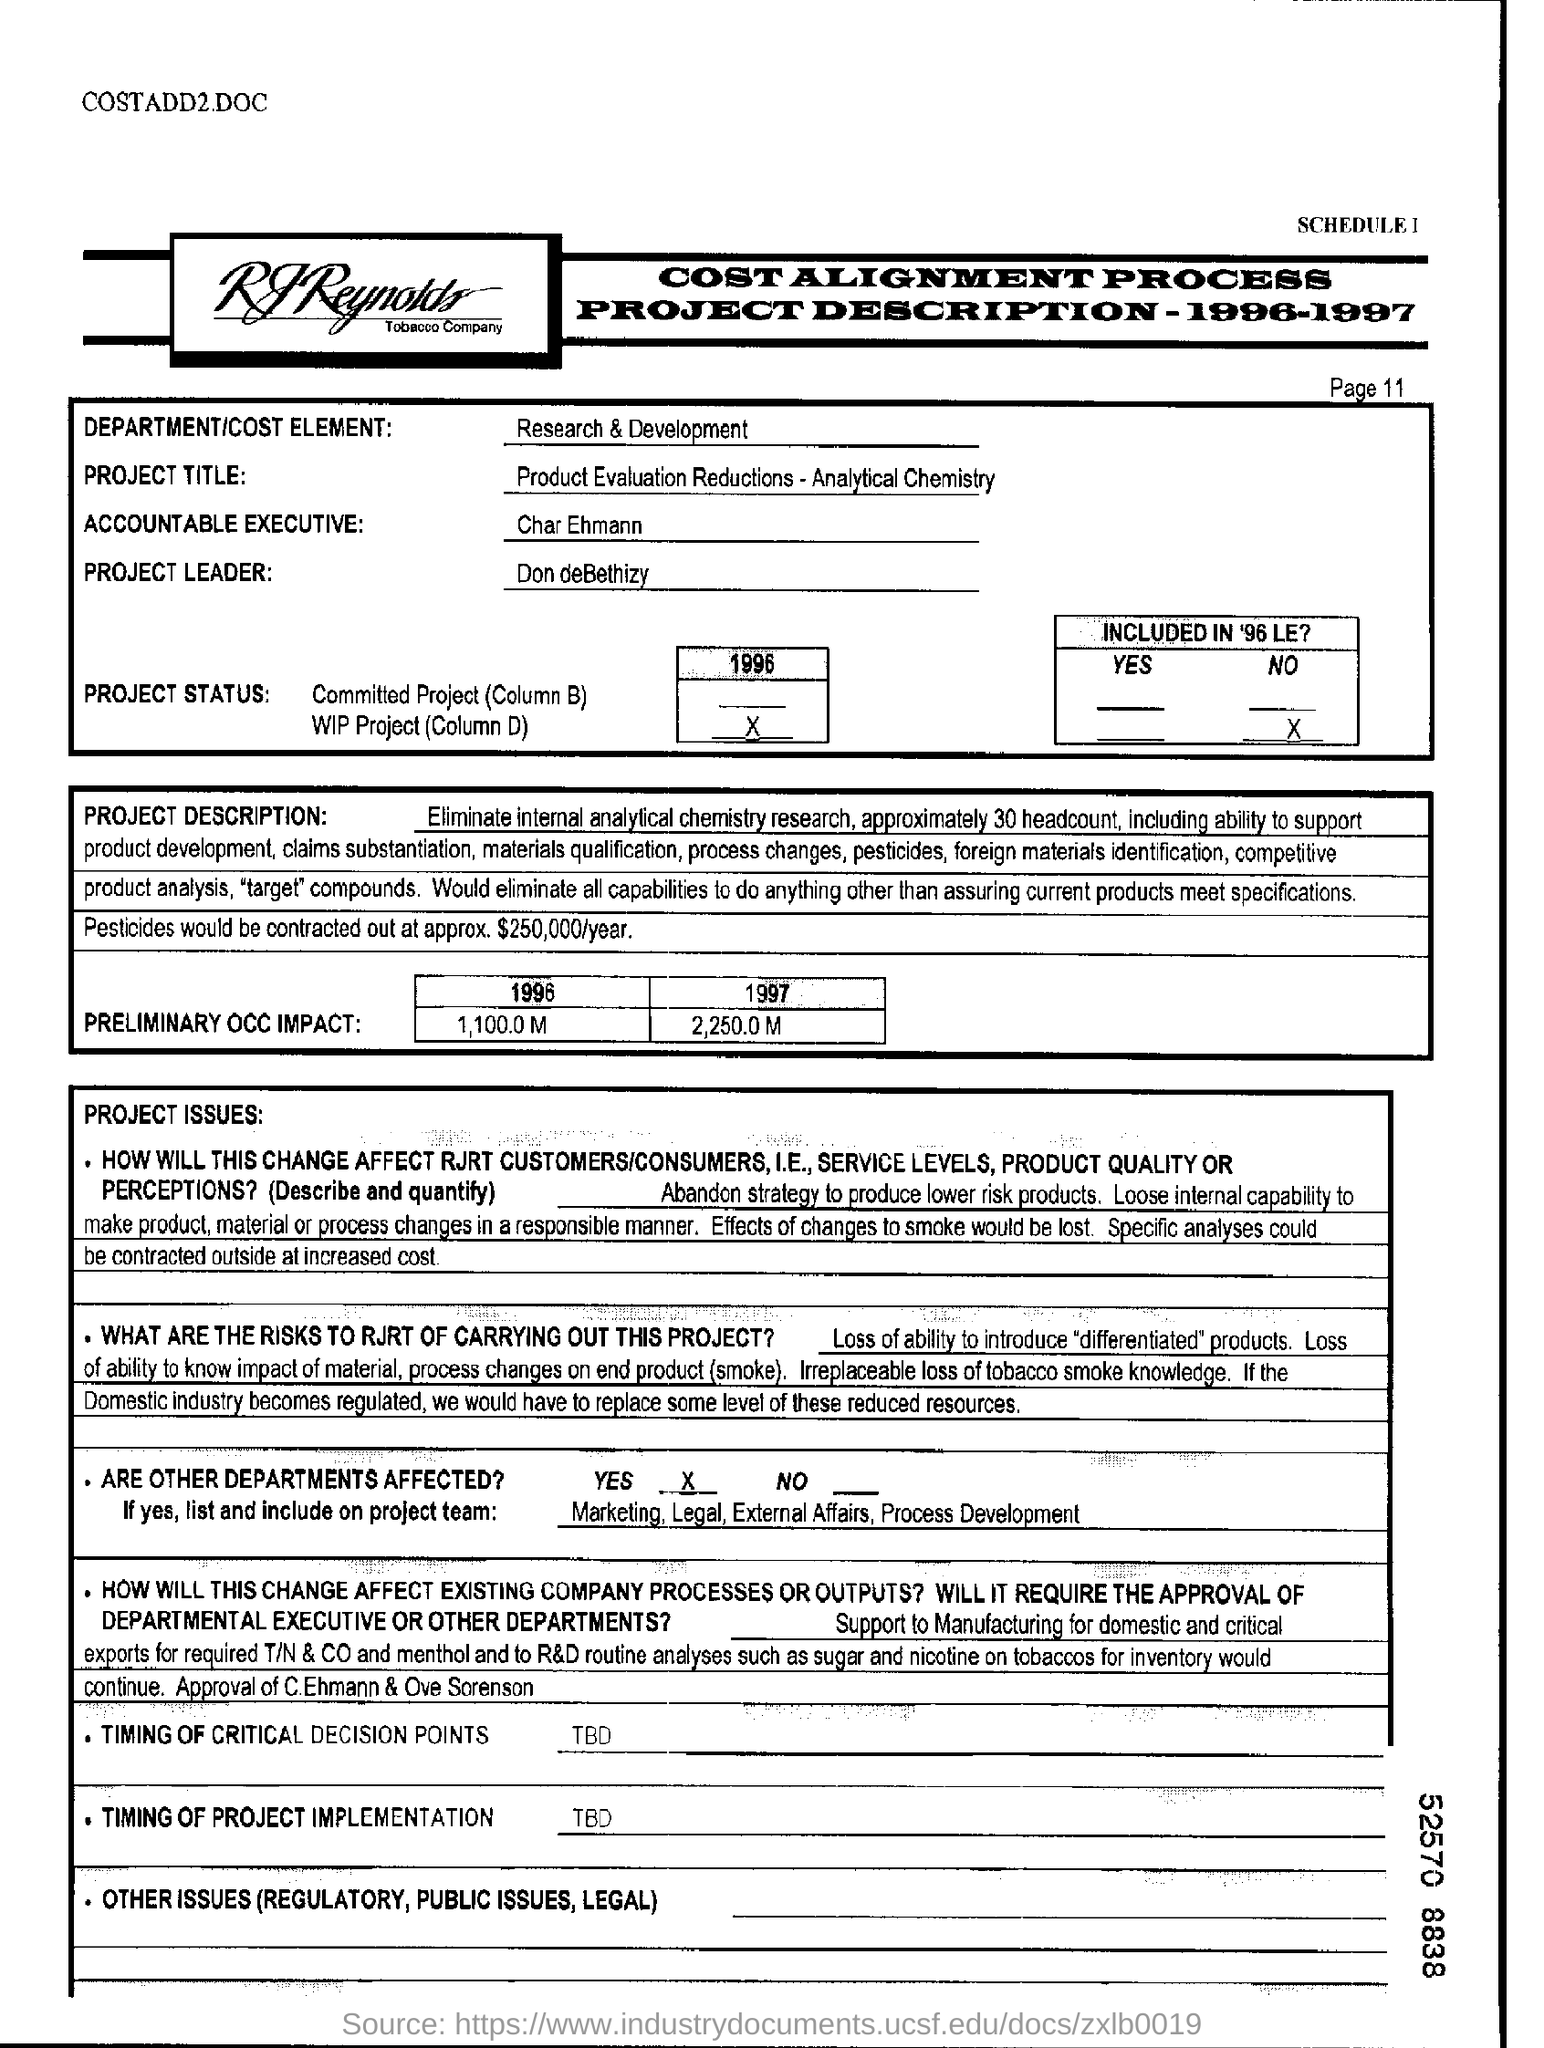Which is the department/cost element given?
Make the answer very short. Research & development. What is the project title?
Your answer should be very brief. Product Evaluation Reductions- Analytical Chemistry. What is the designation of Don deBethizy?
Make the answer very short. Project leader. Who is the accountable executive?
Ensure brevity in your answer.  Char ehmann. Which other departments are affected?
Provide a succinct answer. Marketing, Legal, External Affairs, Process Development. 